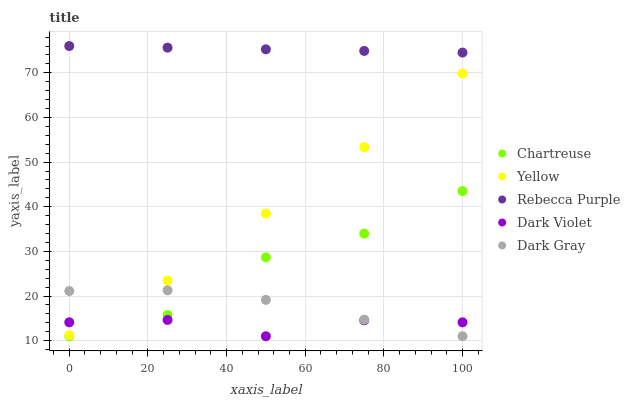Does Dark Violet have the minimum area under the curve?
Answer yes or no. Yes. Does Rebecca Purple have the maximum area under the curve?
Answer yes or no. Yes. Does Chartreuse have the minimum area under the curve?
Answer yes or no. No. Does Chartreuse have the maximum area under the curve?
Answer yes or no. No. Is Rebecca Purple the smoothest?
Answer yes or no. Yes. Is Chartreuse the roughest?
Answer yes or no. Yes. Is Dark Violet the smoothest?
Answer yes or no. No. Is Dark Violet the roughest?
Answer yes or no. No. Does Dark Gray have the lowest value?
Answer yes or no. Yes. Does Rebecca Purple have the lowest value?
Answer yes or no. No. Does Rebecca Purple have the highest value?
Answer yes or no. Yes. Does Chartreuse have the highest value?
Answer yes or no. No. Is Yellow less than Rebecca Purple?
Answer yes or no. Yes. Is Rebecca Purple greater than Dark Gray?
Answer yes or no. Yes. Does Chartreuse intersect Dark Violet?
Answer yes or no. Yes. Is Chartreuse less than Dark Violet?
Answer yes or no. No. Is Chartreuse greater than Dark Violet?
Answer yes or no. No. Does Yellow intersect Rebecca Purple?
Answer yes or no. No. 